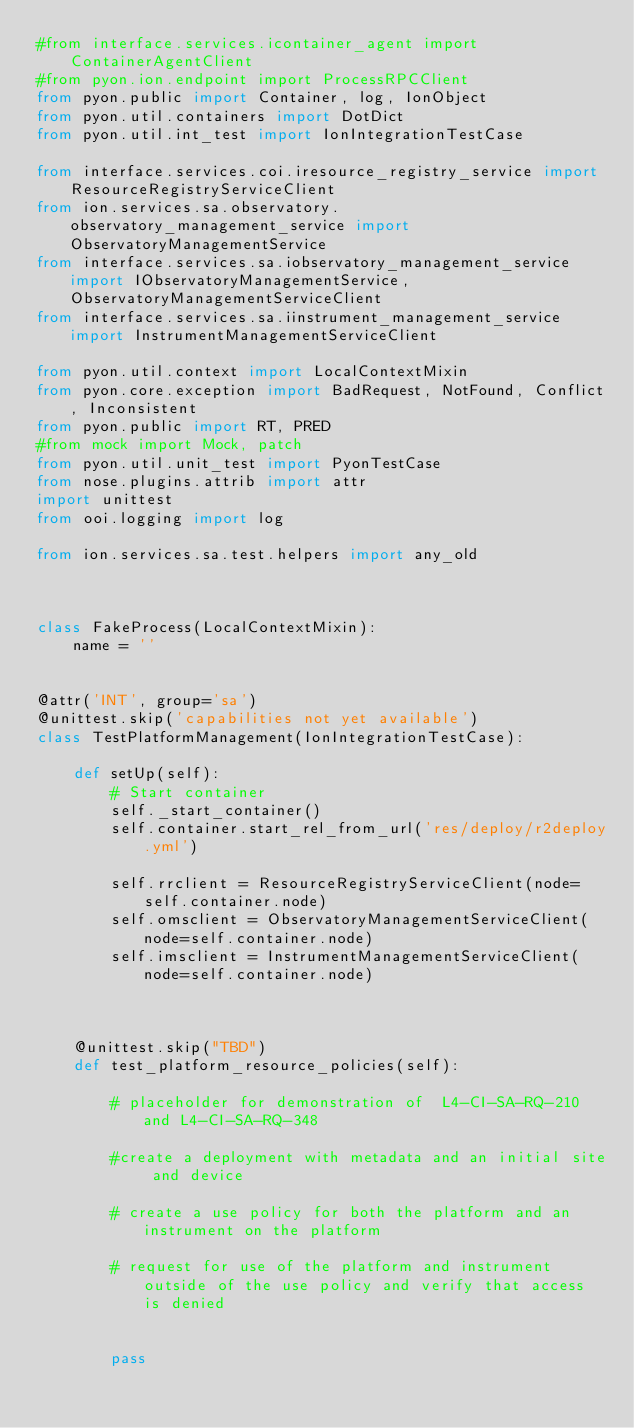<code> <loc_0><loc_0><loc_500><loc_500><_Python_>#from interface.services.icontainer_agent import ContainerAgentClient
#from pyon.ion.endpoint import ProcessRPCClient
from pyon.public import Container, log, IonObject
from pyon.util.containers import DotDict
from pyon.util.int_test import IonIntegrationTestCase

from interface.services.coi.iresource_registry_service import ResourceRegistryServiceClient
from ion.services.sa.observatory.observatory_management_service import ObservatoryManagementService
from interface.services.sa.iobservatory_management_service import IObservatoryManagementService, ObservatoryManagementServiceClient
from interface.services.sa.iinstrument_management_service import InstrumentManagementServiceClient

from pyon.util.context import LocalContextMixin
from pyon.core.exception import BadRequest, NotFound, Conflict, Inconsistent
from pyon.public import RT, PRED
#from mock import Mock, patch
from pyon.util.unit_test import PyonTestCase
from nose.plugins.attrib import attr
import unittest
from ooi.logging import log

from ion.services.sa.test.helpers import any_old



class FakeProcess(LocalContextMixin):
    name = ''


@attr('INT', group='sa')
@unittest.skip('capabilities not yet available')
class TestPlatformManagement(IonIntegrationTestCase):

    def setUp(self):
        # Start container
        self._start_container()
        self.container.start_rel_from_url('res/deploy/r2deploy.yml')

        self.rrclient = ResourceRegistryServiceClient(node=self.container.node)
        self.omsclient = ObservatoryManagementServiceClient(node=self.container.node)
        self.imsclient = InstrumentManagementServiceClient(node=self.container.node)



    @unittest.skip("TBD")
    def test_platform_resource_policies(self):

        # placeholder for demonstration of  L4-CI-SA-RQ-210 and L4-CI-SA-RQ-348

        #create a deployment with metadata and an initial site and device

        # create a use policy for both the platform and an instrument on the platform

        # request for use of the platform and instrument outside of the use policy and verify that access is denied


        pass
</code> 